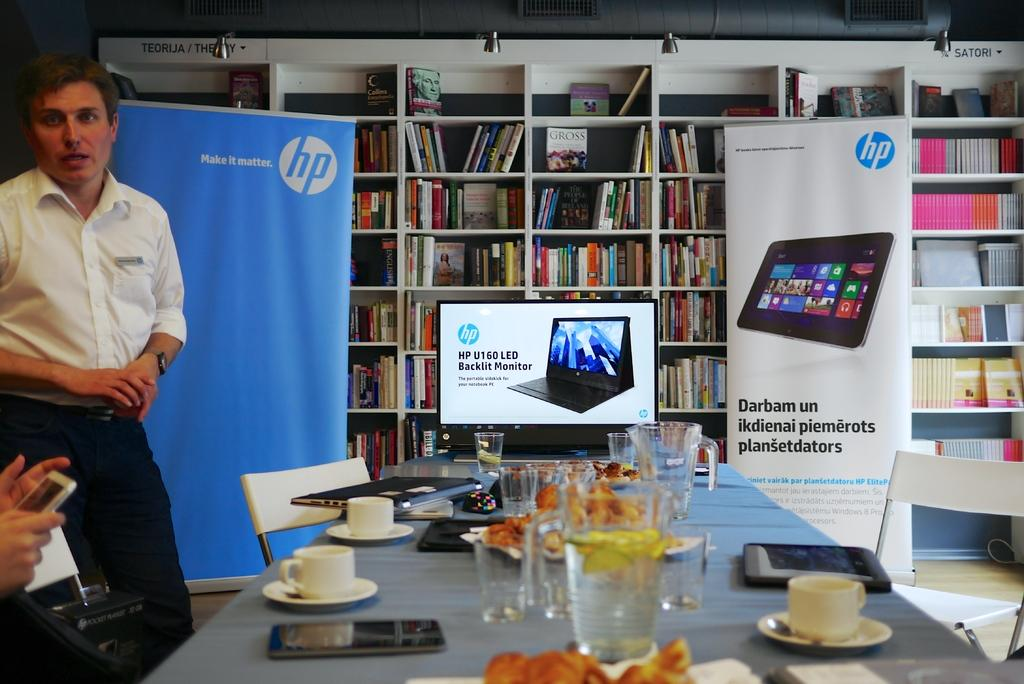Provide a one-sentence caption for the provided image. Man making a presentation in front of others about HP products. 